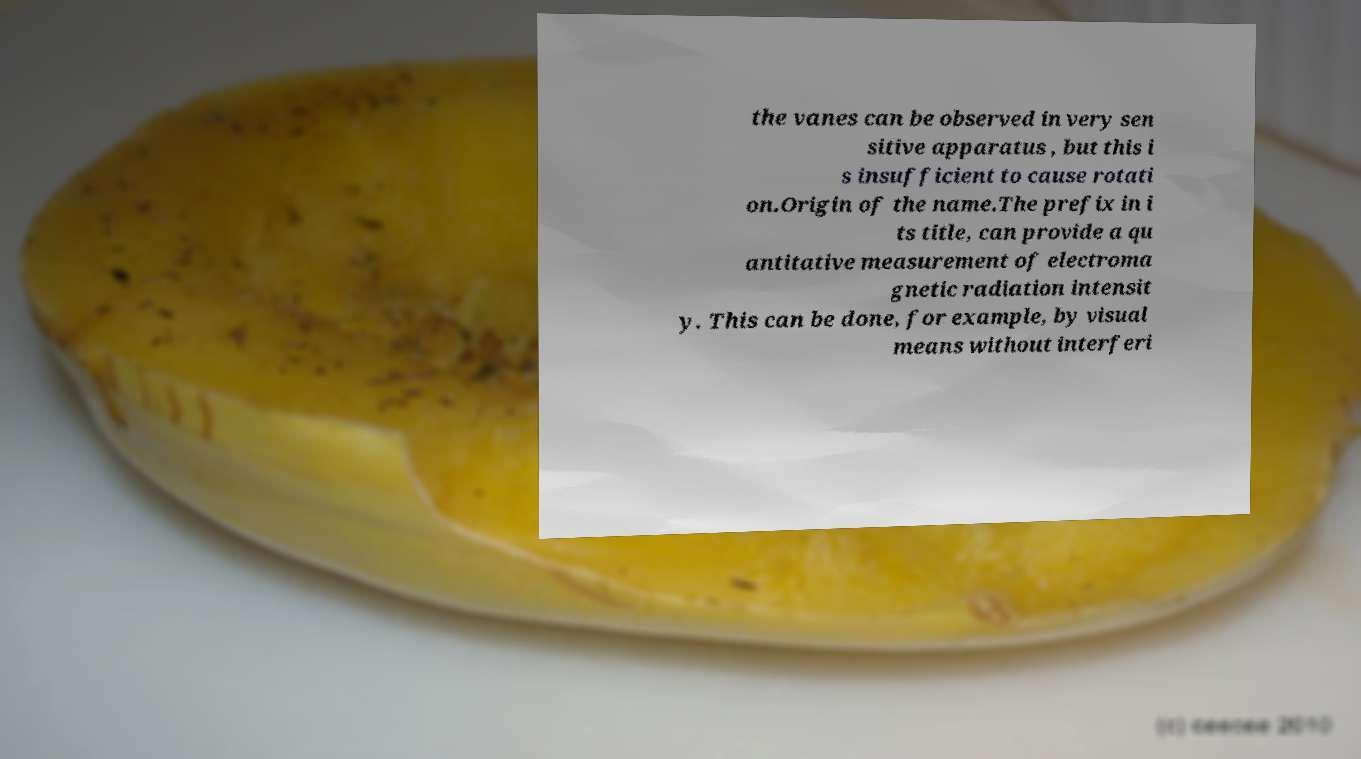I need the written content from this picture converted into text. Can you do that? the vanes can be observed in very sen sitive apparatus , but this i s insufficient to cause rotati on.Origin of the name.The prefix in i ts title, can provide a qu antitative measurement of electroma gnetic radiation intensit y. This can be done, for example, by visual means without interferi 